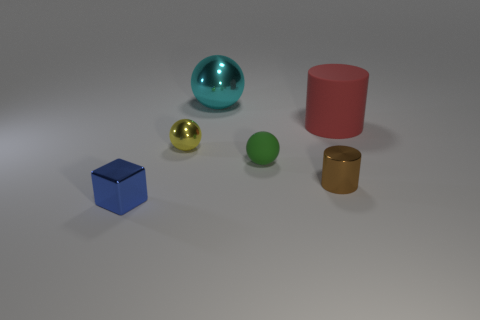Subtract all matte spheres. How many spheres are left? 2 Subtract 1 spheres. How many spheres are left? 2 Subtract all cylinders. How many objects are left? 4 Subtract all purple balls. Subtract all blue cubes. How many balls are left? 3 Add 3 green objects. How many objects exist? 9 Subtract 0 cyan cubes. How many objects are left? 6 Subtract all yellow metal things. Subtract all big metal spheres. How many objects are left? 4 Add 4 rubber things. How many rubber things are left? 6 Add 2 big cyan metallic spheres. How many big cyan metallic spheres exist? 3 